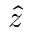<formula> <loc_0><loc_0><loc_500><loc_500>\hat { z }</formula> 